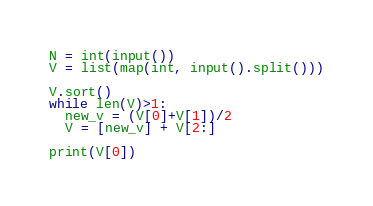Convert code to text. <code><loc_0><loc_0><loc_500><loc_500><_Python_>N = int(input())
V = list(map(int, input().split()))

V.sort()
while len(V)>1:
  new_v = (V[0]+V[1])/2
  V = [new_v] + V[2:]

print(V[0])</code> 